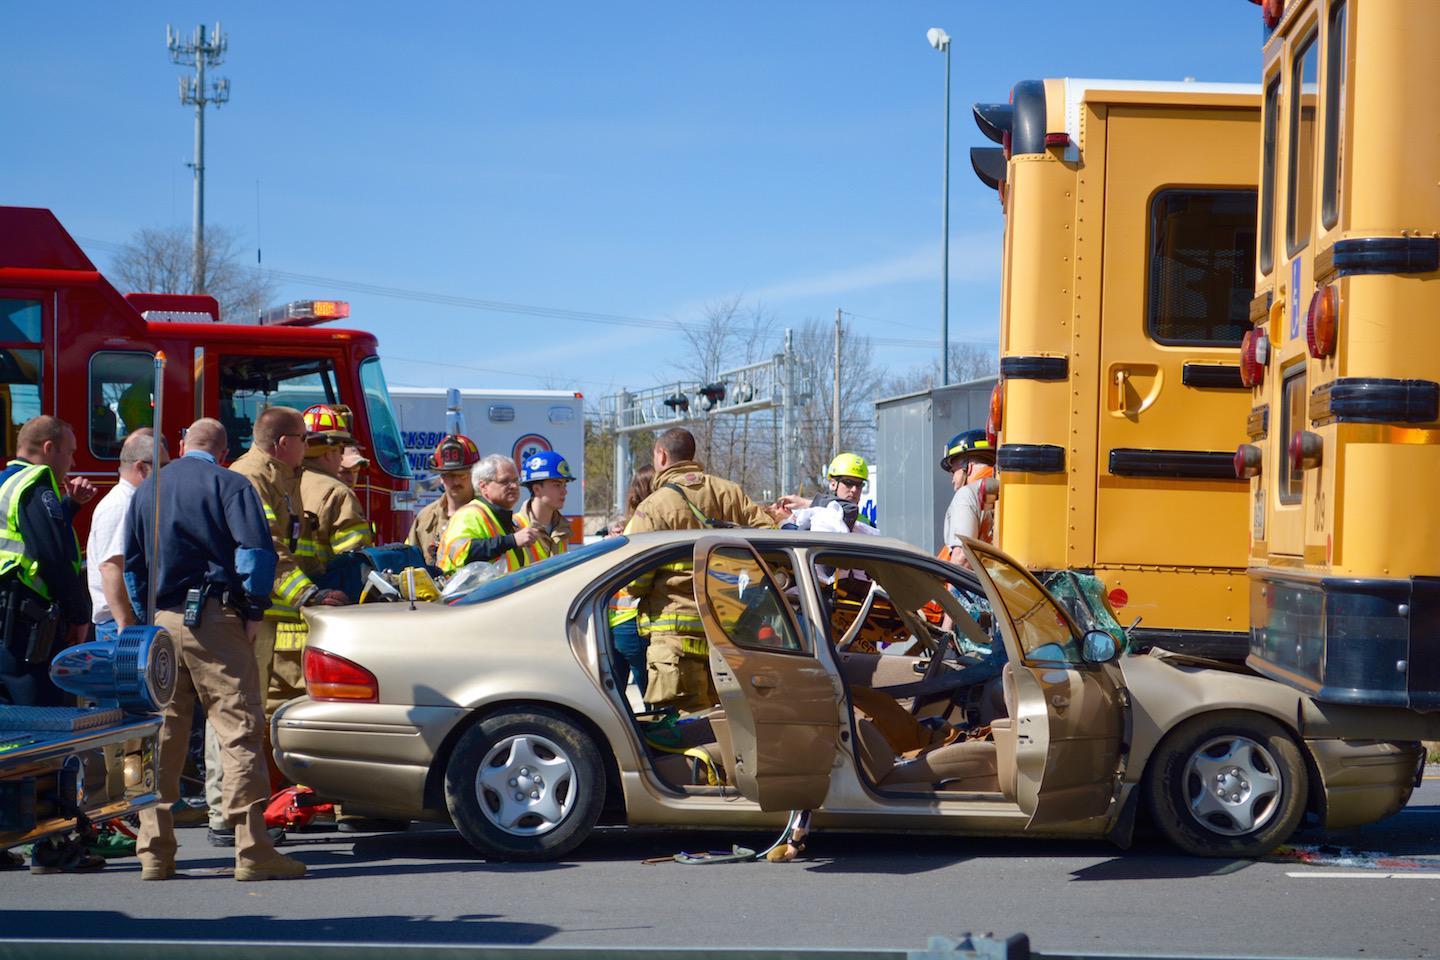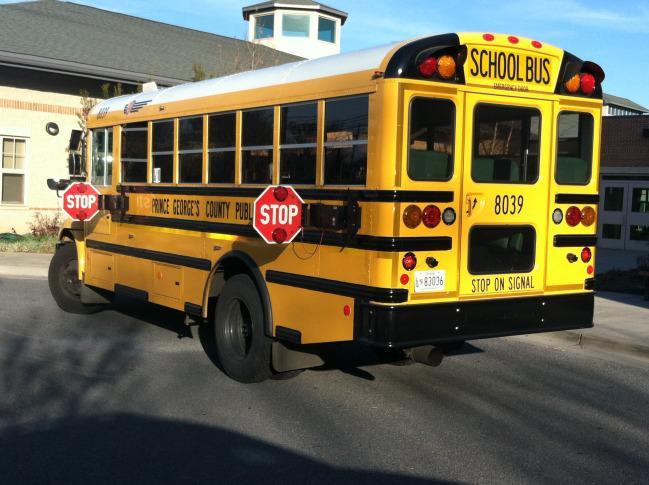The first image is the image on the left, the second image is the image on the right. Assess this claim about the two images: "The image on the right shows the back end of at least one bus.". Correct or not? Answer yes or no. Yes. The first image is the image on the left, the second image is the image on the right. Analyze the images presented: Is the assertion "An emergency is being dealt with right next to a school bus in one of the pictures." valid? Answer yes or no. Yes. 